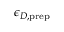Convert formula to latex. <formula><loc_0><loc_0><loc_500><loc_500>\epsilon _ { D , p r e p }</formula> 